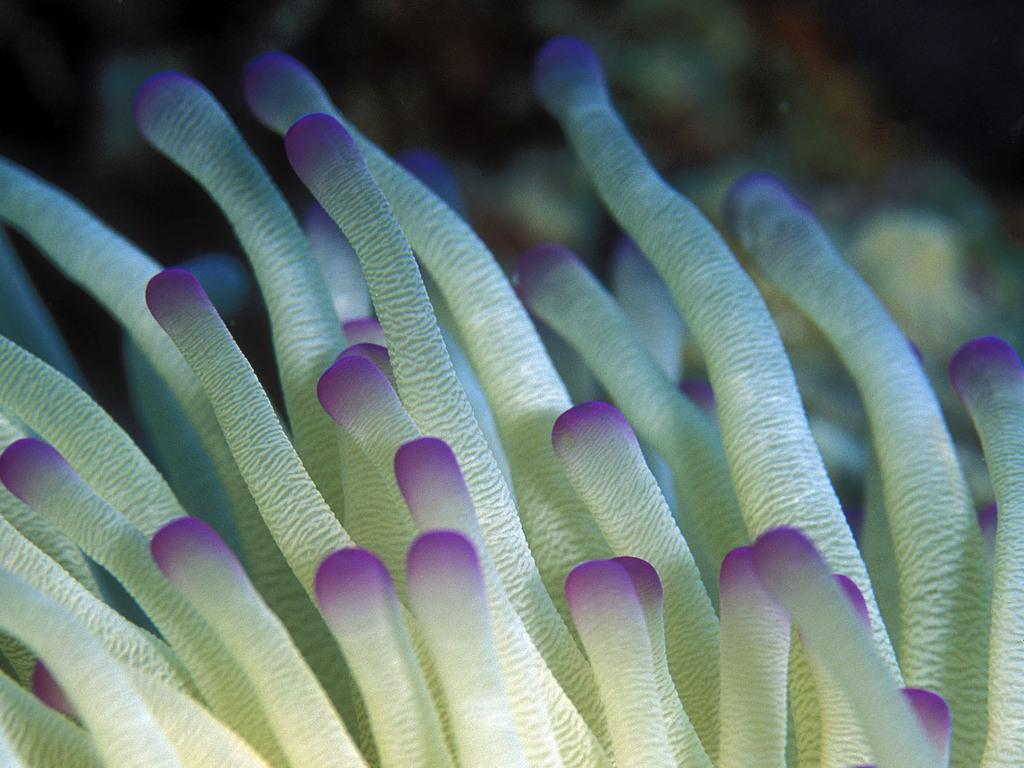What is the main subject of the image? The main subject of the image is a Condylactis. Where is the Condylactis located in the image? The Condylactis is in the center of the image. What colors can be seen on the Condylactis? The Condylactis is pink and cream in color. What type of silver carriage can be seen in the image? There is no silver carriage present in the image; it features a Condylactis. How many sacks are visible in the image? There are no sacks visible in the image; it features a Condylactis. 